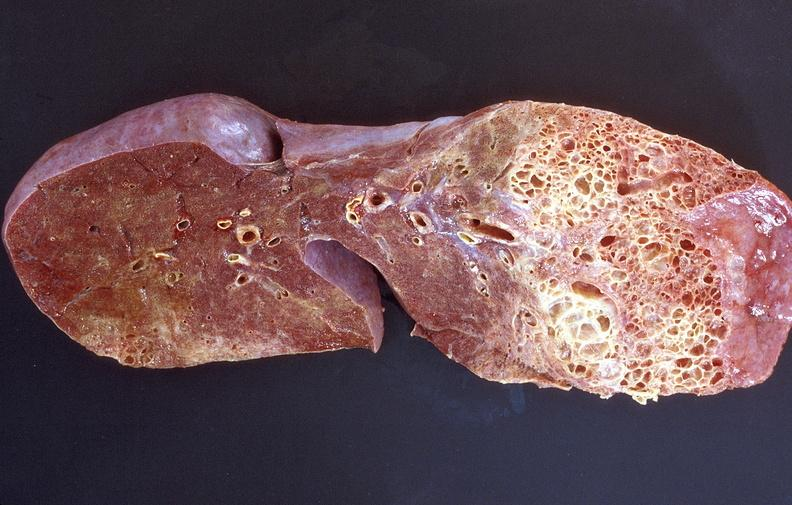does this image show lung fibrosis, scleroderma?
Answer the question using a single word or phrase. Yes 